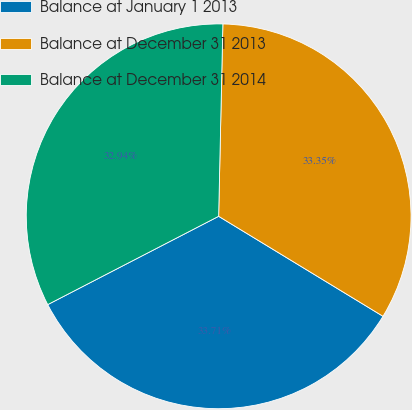Convert chart to OTSL. <chart><loc_0><loc_0><loc_500><loc_500><pie_chart><fcel>Balance at January 1 2013<fcel>Balance at December 31 2013<fcel>Balance at December 31 2014<nl><fcel>33.71%<fcel>33.35%<fcel>32.94%<nl></chart> 